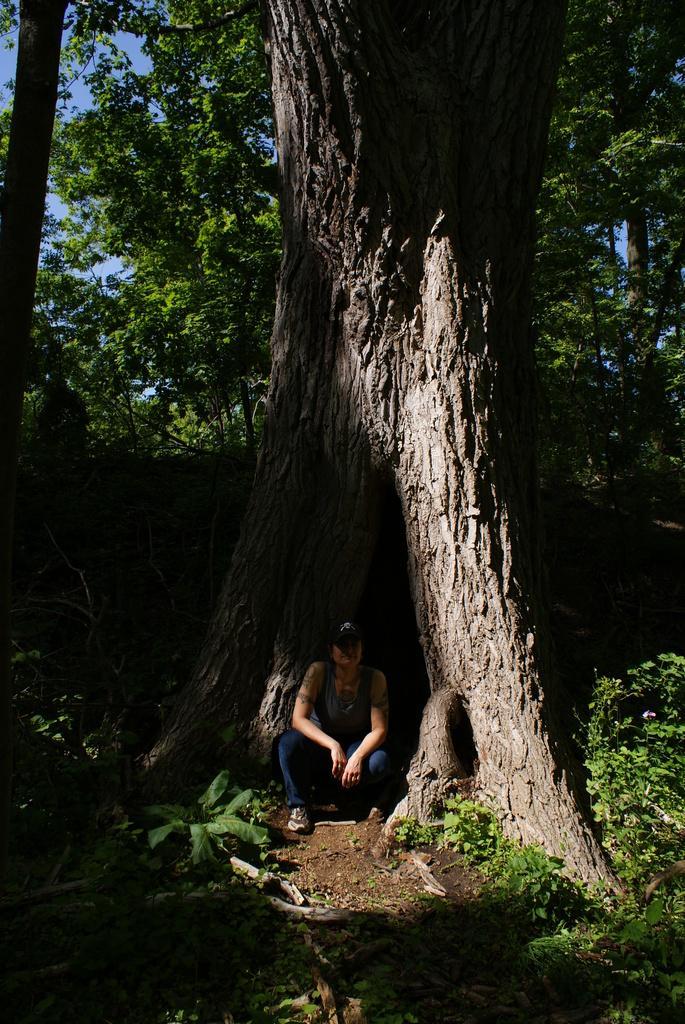Please provide a concise description of this image. In this image in the center there is one person sitting, in the background there are some trees and at the bottom there is sand and plants. 